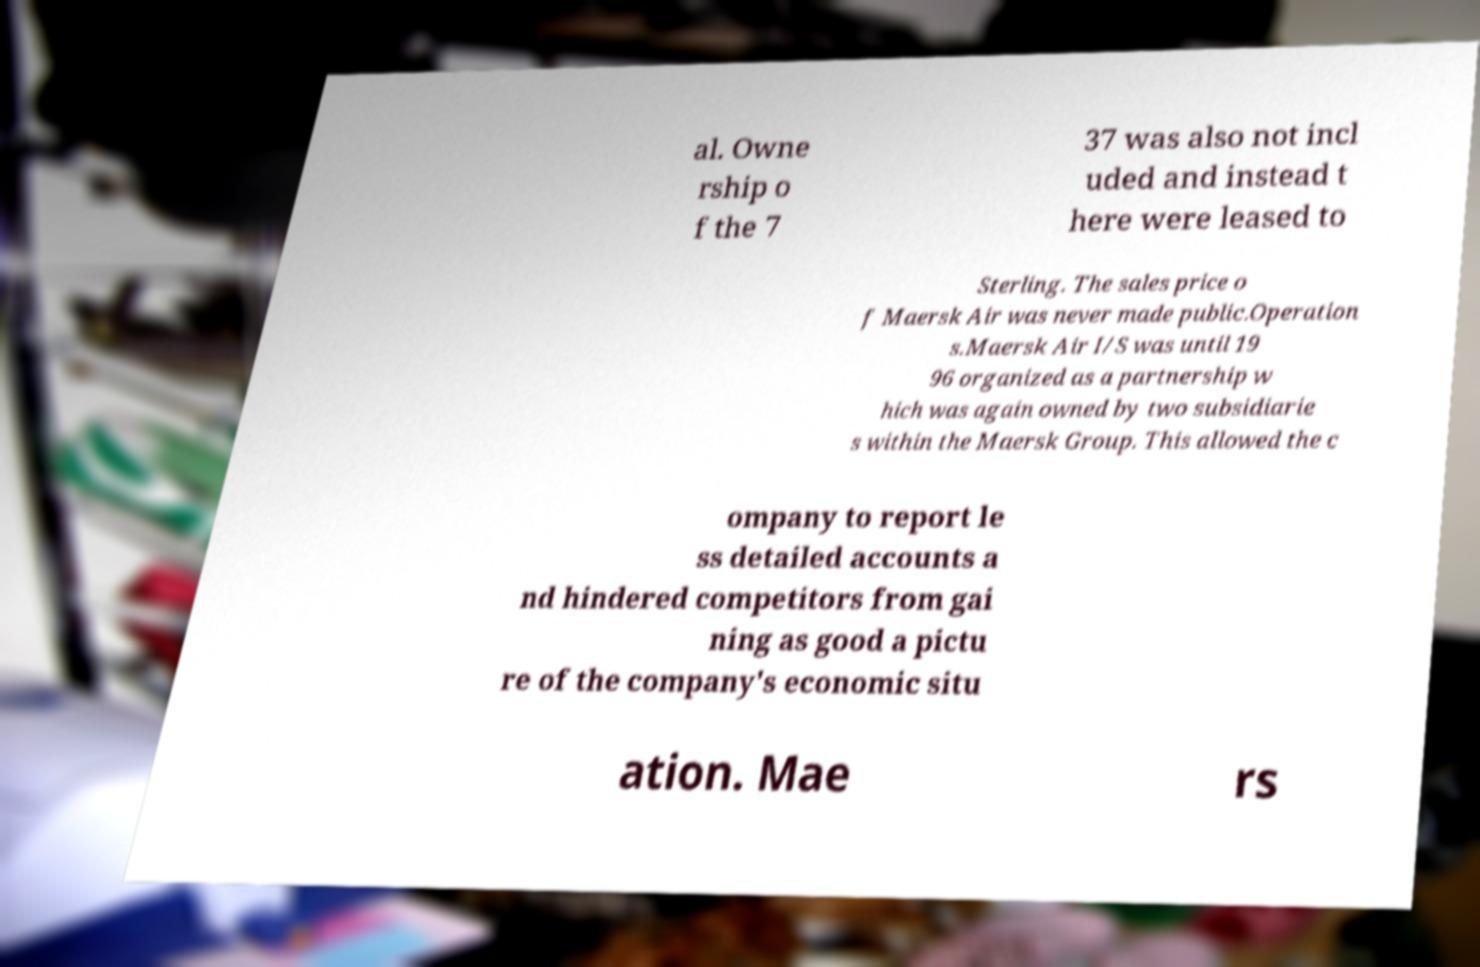Could you assist in decoding the text presented in this image and type it out clearly? al. Owne rship o f the 7 37 was also not incl uded and instead t here were leased to Sterling. The sales price o f Maersk Air was never made public.Operation s.Maersk Air I/S was until 19 96 organized as a partnership w hich was again owned by two subsidiarie s within the Maersk Group. This allowed the c ompany to report le ss detailed accounts a nd hindered competitors from gai ning as good a pictu re of the company's economic situ ation. Mae rs 